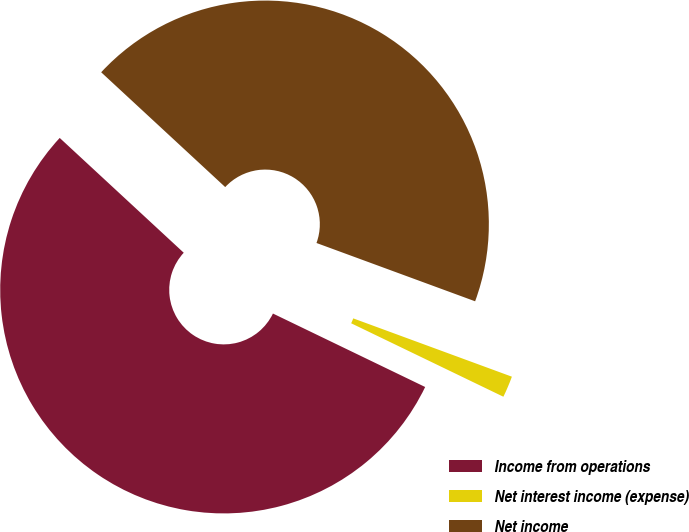Convert chart. <chart><loc_0><loc_0><loc_500><loc_500><pie_chart><fcel>Income from operations<fcel>Net interest income (expense)<fcel>Net income<nl><fcel>54.73%<fcel>1.55%<fcel>43.72%<nl></chart> 